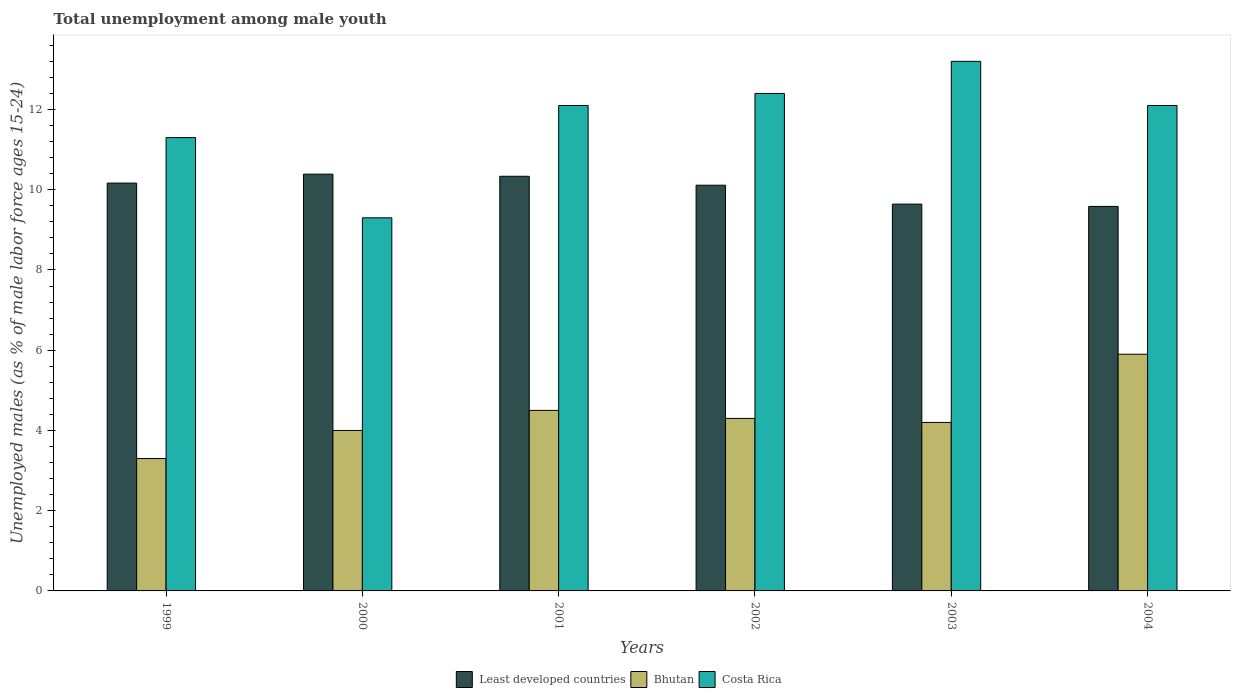How many groups of bars are there?
Your answer should be very brief. 6. Are the number of bars per tick equal to the number of legend labels?
Your answer should be very brief. Yes. How many bars are there on the 2nd tick from the left?
Ensure brevity in your answer.  3. In how many cases, is the number of bars for a given year not equal to the number of legend labels?
Make the answer very short. 0. What is the percentage of unemployed males in in Least developed countries in 2003?
Ensure brevity in your answer.  9.64. Across all years, what is the maximum percentage of unemployed males in in Least developed countries?
Make the answer very short. 10.39. Across all years, what is the minimum percentage of unemployed males in in Costa Rica?
Provide a succinct answer. 9.3. What is the total percentage of unemployed males in in Bhutan in the graph?
Offer a terse response. 26.2. What is the difference between the percentage of unemployed males in in Least developed countries in 2003 and that in 2004?
Offer a very short reply. 0.06. What is the difference between the percentage of unemployed males in in Bhutan in 2000 and the percentage of unemployed males in in Costa Rica in 2004?
Your answer should be very brief. -8.1. What is the average percentage of unemployed males in in Least developed countries per year?
Make the answer very short. 10.04. In the year 1999, what is the difference between the percentage of unemployed males in in Costa Rica and percentage of unemployed males in in Least developed countries?
Your response must be concise. 1.13. In how many years, is the percentage of unemployed males in in Bhutan greater than 11.2 %?
Give a very brief answer. 0. What is the ratio of the percentage of unemployed males in in Bhutan in 2001 to that in 2003?
Give a very brief answer. 1.07. What is the difference between the highest and the second highest percentage of unemployed males in in Costa Rica?
Give a very brief answer. 0.8. What is the difference between the highest and the lowest percentage of unemployed males in in Costa Rica?
Make the answer very short. 3.9. What does the 1st bar from the left in 2003 represents?
Your answer should be very brief. Least developed countries. What does the 2nd bar from the right in 2003 represents?
Keep it short and to the point. Bhutan. How many bars are there?
Your answer should be very brief. 18. Are all the bars in the graph horizontal?
Your response must be concise. No. How many years are there in the graph?
Offer a very short reply. 6. Does the graph contain grids?
Your answer should be compact. No. How many legend labels are there?
Offer a terse response. 3. How are the legend labels stacked?
Make the answer very short. Horizontal. What is the title of the graph?
Offer a terse response. Total unemployment among male youth. What is the label or title of the Y-axis?
Your response must be concise. Unemployed males (as % of male labor force ages 15-24). What is the Unemployed males (as % of male labor force ages 15-24) of Least developed countries in 1999?
Offer a very short reply. 10.17. What is the Unemployed males (as % of male labor force ages 15-24) of Bhutan in 1999?
Your answer should be very brief. 3.3. What is the Unemployed males (as % of male labor force ages 15-24) of Costa Rica in 1999?
Your response must be concise. 11.3. What is the Unemployed males (as % of male labor force ages 15-24) in Least developed countries in 2000?
Ensure brevity in your answer.  10.39. What is the Unemployed males (as % of male labor force ages 15-24) in Costa Rica in 2000?
Give a very brief answer. 9.3. What is the Unemployed males (as % of male labor force ages 15-24) in Least developed countries in 2001?
Offer a terse response. 10.34. What is the Unemployed males (as % of male labor force ages 15-24) in Bhutan in 2001?
Provide a succinct answer. 4.5. What is the Unemployed males (as % of male labor force ages 15-24) in Costa Rica in 2001?
Your answer should be very brief. 12.1. What is the Unemployed males (as % of male labor force ages 15-24) in Least developed countries in 2002?
Keep it short and to the point. 10.11. What is the Unemployed males (as % of male labor force ages 15-24) in Bhutan in 2002?
Make the answer very short. 4.3. What is the Unemployed males (as % of male labor force ages 15-24) in Costa Rica in 2002?
Your answer should be compact. 12.4. What is the Unemployed males (as % of male labor force ages 15-24) in Least developed countries in 2003?
Offer a terse response. 9.64. What is the Unemployed males (as % of male labor force ages 15-24) of Bhutan in 2003?
Offer a terse response. 4.2. What is the Unemployed males (as % of male labor force ages 15-24) of Costa Rica in 2003?
Offer a terse response. 13.2. What is the Unemployed males (as % of male labor force ages 15-24) in Least developed countries in 2004?
Your response must be concise. 9.58. What is the Unemployed males (as % of male labor force ages 15-24) in Bhutan in 2004?
Make the answer very short. 5.9. What is the Unemployed males (as % of male labor force ages 15-24) in Costa Rica in 2004?
Make the answer very short. 12.1. Across all years, what is the maximum Unemployed males (as % of male labor force ages 15-24) in Least developed countries?
Keep it short and to the point. 10.39. Across all years, what is the maximum Unemployed males (as % of male labor force ages 15-24) in Bhutan?
Ensure brevity in your answer.  5.9. Across all years, what is the maximum Unemployed males (as % of male labor force ages 15-24) of Costa Rica?
Your answer should be compact. 13.2. Across all years, what is the minimum Unemployed males (as % of male labor force ages 15-24) in Least developed countries?
Your answer should be very brief. 9.58. Across all years, what is the minimum Unemployed males (as % of male labor force ages 15-24) in Bhutan?
Offer a very short reply. 3.3. Across all years, what is the minimum Unemployed males (as % of male labor force ages 15-24) in Costa Rica?
Offer a very short reply. 9.3. What is the total Unemployed males (as % of male labor force ages 15-24) in Least developed countries in the graph?
Offer a very short reply. 60.23. What is the total Unemployed males (as % of male labor force ages 15-24) in Bhutan in the graph?
Keep it short and to the point. 26.2. What is the total Unemployed males (as % of male labor force ages 15-24) of Costa Rica in the graph?
Offer a very short reply. 70.4. What is the difference between the Unemployed males (as % of male labor force ages 15-24) of Least developed countries in 1999 and that in 2000?
Provide a succinct answer. -0.22. What is the difference between the Unemployed males (as % of male labor force ages 15-24) in Costa Rica in 1999 and that in 2000?
Keep it short and to the point. 2. What is the difference between the Unemployed males (as % of male labor force ages 15-24) in Least developed countries in 1999 and that in 2001?
Your response must be concise. -0.17. What is the difference between the Unemployed males (as % of male labor force ages 15-24) in Costa Rica in 1999 and that in 2001?
Your answer should be very brief. -0.8. What is the difference between the Unemployed males (as % of male labor force ages 15-24) of Least developed countries in 1999 and that in 2002?
Keep it short and to the point. 0.05. What is the difference between the Unemployed males (as % of male labor force ages 15-24) of Bhutan in 1999 and that in 2002?
Provide a succinct answer. -1. What is the difference between the Unemployed males (as % of male labor force ages 15-24) of Costa Rica in 1999 and that in 2002?
Your answer should be very brief. -1.1. What is the difference between the Unemployed males (as % of male labor force ages 15-24) in Least developed countries in 1999 and that in 2003?
Make the answer very short. 0.52. What is the difference between the Unemployed males (as % of male labor force ages 15-24) in Bhutan in 1999 and that in 2003?
Offer a very short reply. -0.9. What is the difference between the Unemployed males (as % of male labor force ages 15-24) in Costa Rica in 1999 and that in 2003?
Ensure brevity in your answer.  -1.9. What is the difference between the Unemployed males (as % of male labor force ages 15-24) of Least developed countries in 1999 and that in 2004?
Offer a terse response. 0.58. What is the difference between the Unemployed males (as % of male labor force ages 15-24) of Costa Rica in 1999 and that in 2004?
Make the answer very short. -0.8. What is the difference between the Unemployed males (as % of male labor force ages 15-24) in Least developed countries in 2000 and that in 2001?
Ensure brevity in your answer.  0.05. What is the difference between the Unemployed males (as % of male labor force ages 15-24) in Least developed countries in 2000 and that in 2002?
Give a very brief answer. 0.28. What is the difference between the Unemployed males (as % of male labor force ages 15-24) of Bhutan in 2000 and that in 2002?
Your response must be concise. -0.3. What is the difference between the Unemployed males (as % of male labor force ages 15-24) of Costa Rica in 2000 and that in 2002?
Provide a succinct answer. -3.1. What is the difference between the Unemployed males (as % of male labor force ages 15-24) of Least developed countries in 2000 and that in 2003?
Give a very brief answer. 0.75. What is the difference between the Unemployed males (as % of male labor force ages 15-24) in Costa Rica in 2000 and that in 2003?
Offer a very short reply. -3.9. What is the difference between the Unemployed males (as % of male labor force ages 15-24) in Least developed countries in 2000 and that in 2004?
Give a very brief answer. 0.8. What is the difference between the Unemployed males (as % of male labor force ages 15-24) in Costa Rica in 2000 and that in 2004?
Provide a succinct answer. -2.8. What is the difference between the Unemployed males (as % of male labor force ages 15-24) of Least developed countries in 2001 and that in 2002?
Offer a terse response. 0.22. What is the difference between the Unemployed males (as % of male labor force ages 15-24) in Bhutan in 2001 and that in 2002?
Give a very brief answer. 0.2. What is the difference between the Unemployed males (as % of male labor force ages 15-24) of Costa Rica in 2001 and that in 2002?
Give a very brief answer. -0.3. What is the difference between the Unemployed males (as % of male labor force ages 15-24) of Least developed countries in 2001 and that in 2003?
Offer a terse response. 0.69. What is the difference between the Unemployed males (as % of male labor force ages 15-24) in Bhutan in 2001 and that in 2003?
Ensure brevity in your answer.  0.3. What is the difference between the Unemployed males (as % of male labor force ages 15-24) in Least developed countries in 2001 and that in 2004?
Offer a very short reply. 0.75. What is the difference between the Unemployed males (as % of male labor force ages 15-24) in Bhutan in 2001 and that in 2004?
Make the answer very short. -1.4. What is the difference between the Unemployed males (as % of male labor force ages 15-24) in Least developed countries in 2002 and that in 2003?
Your response must be concise. 0.47. What is the difference between the Unemployed males (as % of male labor force ages 15-24) of Bhutan in 2002 and that in 2003?
Provide a succinct answer. 0.1. What is the difference between the Unemployed males (as % of male labor force ages 15-24) in Least developed countries in 2002 and that in 2004?
Offer a terse response. 0.53. What is the difference between the Unemployed males (as % of male labor force ages 15-24) of Bhutan in 2002 and that in 2004?
Your answer should be compact. -1.6. What is the difference between the Unemployed males (as % of male labor force ages 15-24) in Least developed countries in 2003 and that in 2004?
Ensure brevity in your answer.  0.06. What is the difference between the Unemployed males (as % of male labor force ages 15-24) of Costa Rica in 2003 and that in 2004?
Ensure brevity in your answer.  1.1. What is the difference between the Unemployed males (as % of male labor force ages 15-24) in Least developed countries in 1999 and the Unemployed males (as % of male labor force ages 15-24) in Bhutan in 2000?
Keep it short and to the point. 6.17. What is the difference between the Unemployed males (as % of male labor force ages 15-24) of Least developed countries in 1999 and the Unemployed males (as % of male labor force ages 15-24) of Costa Rica in 2000?
Ensure brevity in your answer.  0.87. What is the difference between the Unemployed males (as % of male labor force ages 15-24) of Least developed countries in 1999 and the Unemployed males (as % of male labor force ages 15-24) of Bhutan in 2001?
Give a very brief answer. 5.67. What is the difference between the Unemployed males (as % of male labor force ages 15-24) of Least developed countries in 1999 and the Unemployed males (as % of male labor force ages 15-24) of Costa Rica in 2001?
Your response must be concise. -1.93. What is the difference between the Unemployed males (as % of male labor force ages 15-24) of Bhutan in 1999 and the Unemployed males (as % of male labor force ages 15-24) of Costa Rica in 2001?
Provide a succinct answer. -8.8. What is the difference between the Unemployed males (as % of male labor force ages 15-24) in Least developed countries in 1999 and the Unemployed males (as % of male labor force ages 15-24) in Bhutan in 2002?
Your answer should be compact. 5.87. What is the difference between the Unemployed males (as % of male labor force ages 15-24) of Least developed countries in 1999 and the Unemployed males (as % of male labor force ages 15-24) of Costa Rica in 2002?
Give a very brief answer. -2.23. What is the difference between the Unemployed males (as % of male labor force ages 15-24) of Least developed countries in 1999 and the Unemployed males (as % of male labor force ages 15-24) of Bhutan in 2003?
Provide a succinct answer. 5.97. What is the difference between the Unemployed males (as % of male labor force ages 15-24) in Least developed countries in 1999 and the Unemployed males (as % of male labor force ages 15-24) in Costa Rica in 2003?
Provide a succinct answer. -3.03. What is the difference between the Unemployed males (as % of male labor force ages 15-24) of Bhutan in 1999 and the Unemployed males (as % of male labor force ages 15-24) of Costa Rica in 2003?
Make the answer very short. -9.9. What is the difference between the Unemployed males (as % of male labor force ages 15-24) in Least developed countries in 1999 and the Unemployed males (as % of male labor force ages 15-24) in Bhutan in 2004?
Ensure brevity in your answer.  4.27. What is the difference between the Unemployed males (as % of male labor force ages 15-24) of Least developed countries in 1999 and the Unemployed males (as % of male labor force ages 15-24) of Costa Rica in 2004?
Offer a terse response. -1.93. What is the difference between the Unemployed males (as % of male labor force ages 15-24) of Least developed countries in 2000 and the Unemployed males (as % of male labor force ages 15-24) of Bhutan in 2001?
Give a very brief answer. 5.89. What is the difference between the Unemployed males (as % of male labor force ages 15-24) in Least developed countries in 2000 and the Unemployed males (as % of male labor force ages 15-24) in Costa Rica in 2001?
Offer a terse response. -1.71. What is the difference between the Unemployed males (as % of male labor force ages 15-24) of Least developed countries in 2000 and the Unemployed males (as % of male labor force ages 15-24) of Bhutan in 2002?
Your answer should be compact. 6.09. What is the difference between the Unemployed males (as % of male labor force ages 15-24) in Least developed countries in 2000 and the Unemployed males (as % of male labor force ages 15-24) in Costa Rica in 2002?
Provide a succinct answer. -2.01. What is the difference between the Unemployed males (as % of male labor force ages 15-24) of Bhutan in 2000 and the Unemployed males (as % of male labor force ages 15-24) of Costa Rica in 2002?
Ensure brevity in your answer.  -8.4. What is the difference between the Unemployed males (as % of male labor force ages 15-24) in Least developed countries in 2000 and the Unemployed males (as % of male labor force ages 15-24) in Bhutan in 2003?
Make the answer very short. 6.19. What is the difference between the Unemployed males (as % of male labor force ages 15-24) of Least developed countries in 2000 and the Unemployed males (as % of male labor force ages 15-24) of Costa Rica in 2003?
Provide a short and direct response. -2.81. What is the difference between the Unemployed males (as % of male labor force ages 15-24) in Least developed countries in 2000 and the Unemployed males (as % of male labor force ages 15-24) in Bhutan in 2004?
Your answer should be very brief. 4.49. What is the difference between the Unemployed males (as % of male labor force ages 15-24) in Least developed countries in 2000 and the Unemployed males (as % of male labor force ages 15-24) in Costa Rica in 2004?
Keep it short and to the point. -1.71. What is the difference between the Unemployed males (as % of male labor force ages 15-24) in Least developed countries in 2001 and the Unemployed males (as % of male labor force ages 15-24) in Bhutan in 2002?
Provide a short and direct response. 6.04. What is the difference between the Unemployed males (as % of male labor force ages 15-24) of Least developed countries in 2001 and the Unemployed males (as % of male labor force ages 15-24) of Costa Rica in 2002?
Make the answer very short. -2.06. What is the difference between the Unemployed males (as % of male labor force ages 15-24) of Least developed countries in 2001 and the Unemployed males (as % of male labor force ages 15-24) of Bhutan in 2003?
Provide a succinct answer. 6.14. What is the difference between the Unemployed males (as % of male labor force ages 15-24) of Least developed countries in 2001 and the Unemployed males (as % of male labor force ages 15-24) of Costa Rica in 2003?
Provide a short and direct response. -2.86. What is the difference between the Unemployed males (as % of male labor force ages 15-24) in Bhutan in 2001 and the Unemployed males (as % of male labor force ages 15-24) in Costa Rica in 2003?
Provide a succinct answer. -8.7. What is the difference between the Unemployed males (as % of male labor force ages 15-24) of Least developed countries in 2001 and the Unemployed males (as % of male labor force ages 15-24) of Bhutan in 2004?
Your answer should be compact. 4.44. What is the difference between the Unemployed males (as % of male labor force ages 15-24) of Least developed countries in 2001 and the Unemployed males (as % of male labor force ages 15-24) of Costa Rica in 2004?
Your answer should be compact. -1.76. What is the difference between the Unemployed males (as % of male labor force ages 15-24) in Least developed countries in 2002 and the Unemployed males (as % of male labor force ages 15-24) in Bhutan in 2003?
Make the answer very short. 5.91. What is the difference between the Unemployed males (as % of male labor force ages 15-24) of Least developed countries in 2002 and the Unemployed males (as % of male labor force ages 15-24) of Costa Rica in 2003?
Give a very brief answer. -3.09. What is the difference between the Unemployed males (as % of male labor force ages 15-24) in Bhutan in 2002 and the Unemployed males (as % of male labor force ages 15-24) in Costa Rica in 2003?
Make the answer very short. -8.9. What is the difference between the Unemployed males (as % of male labor force ages 15-24) of Least developed countries in 2002 and the Unemployed males (as % of male labor force ages 15-24) of Bhutan in 2004?
Provide a succinct answer. 4.21. What is the difference between the Unemployed males (as % of male labor force ages 15-24) of Least developed countries in 2002 and the Unemployed males (as % of male labor force ages 15-24) of Costa Rica in 2004?
Offer a terse response. -1.99. What is the difference between the Unemployed males (as % of male labor force ages 15-24) in Bhutan in 2002 and the Unemployed males (as % of male labor force ages 15-24) in Costa Rica in 2004?
Offer a very short reply. -7.8. What is the difference between the Unemployed males (as % of male labor force ages 15-24) in Least developed countries in 2003 and the Unemployed males (as % of male labor force ages 15-24) in Bhutan in 2004?
Ensure brevity in your answer.  3.74. What is the difference between the Unemployed males (as % of male labor force ages 15-24) of Least developed countries in 2003 and the Unemployed males (as % of male labor force ages 15-24) of Costa Rica in 2004?
Ensure brevity in your answer.  -2.46. What is the difference between the Unemployed males (as % of male labor force ages 15-24) in Bhutan in 2003 and the Unemployed males (as % of male labor force ages 15-24) in Costa Rica in 2004?
Offer a terse response. -7.9. What is the average Unemployed males (as % of male labor force ages 15-24) in Least developed countries per year?
Provide a short and direct response. 10.04. What is the average Unemployed males (as % of male labor force ages 15-24) of Bhutan per year?
Provide a short and direct response. 4.37. What is the average Unemployed males (as % of male labor force ages 15-24) in Costa Rica per year?
Ensure brevity in your answer.  11.73. In the year 1999, what is the difference between the Unemployed males (as % of male labor force ages 15-24) in Least developed countries and Unemployed males (as % of male labor force ages 15-24) in Bhutan?
Give a very brief answer. 6.87. In the year 1999, what is the difference between the Unemployed males (as % of male labor force ages 15-24) in Least developed countries and Unemployed males (as % of male labor force ages 15-24) in Costa Rica?
Your answer should be very brief. -1.13. In the year 1999, what is the difference between the Unemployed males (as % of male labor force ages 15-24) in Bhutan and Unemployed males (as % of male labor force ages 15-24) in Costa Rica?
Offer a terse response. -8. In the year 2000, what is the difference between the Unemployed males (as % of male labor force ages 15-24) of Least developed countries and Unemployed males (as % of male labor force ages 15-24) of Bhutan?
Your answer should be very brief. 6.39. In the year 2000, what is the difference between the Unemployed males (as % of male labor force ages 15-24) in Least developed countries and Unemployed males (as % of male labor force ages 15-24) in Costa Rica?
Give a very brief answer. 1.09. In the year 2001, what is the difference between the Unemployed males (as % of male labor force ages 15-24) of Least developed countries and Unemployed males (as % of male labor force ages 15-24) of Bhutan?
Your answer should be compact. 5.84. In the year 2001, what is the difference between the Unemployed males (as % of male labor force ages 15-24) of Least developed countries and Unemployed males (as % of male labor force ages 15-24) of Costa Rica?
Offer a very short reply. -1.76. In the year 2001, what is the difference between the Unemployed males (as % of male labor force ages 15-24) of Bhutan and Unemployed males (as % of male labor force ages 15-24) of Costa Rica?
Your response must be concise. -7.6. In the year 2002, what is the difference between the Unemployed males (as % of male labor force ages 15-24) of Least developed countries and Unemployed males (as % of male labor force ages 15-24) of Bhutan?
Your response must be concise. 5.81. In the year 2002, what is the difference between the Unemployed males (as % of male labor force ages 15-24) of Least developed countries and Unemployed males (as % of male labor force ages 15-24) of Costa Rica?
Your answer should be very brief. -2.29. In the year 2002, what is the difference between the Unemployed males (as % of male labor force ages 15-24) in Bhutan and Unemployed males (as % of male labor force ages 15-24) in Costa Rica?
Keep it short and to the point. -8.1. In the year 2003, what is the difference between the Unemployed males (as % of male labor force ages 15-24) in Least developed countries and Unemployed males (as % of male labor force ages 15-24) in Bhutan?
Keep it short and to the point. 5.44. In the year 2003, what is the difference between the Unemployed males (as % of male labor force ages 15-24) in Least developed countries and Unemployed males (as % of male labor force ages 15-24) in Costa Rica?
Ensure brevity in your answer.  -3.56. In the year 2004, what is the difference between the Unemployed males (as % of male labor force ages 15-24) of Least developed countries and Unemployed males (as % of male labor force ages 15-24) of Bhutan?
Keep it short and to the point. 3.68. In the year 2004, what is the difference between the Unemployed males (as % of male labor force ages 15-24) in Least developed countries and Unemployed males (as % of male labor force ages 15-24) in Costa Rica?
Provide a short and direct response. -2.52. In the year 2004, what is the difference between the Unemployed males (as % of male labor force ages 15-24) in Bhutan and Unemployed males (as % of male labor force ages 15-24) in Costa Rica?
Keep it short and to the point. -6.2. What is the ratio of the Unemployed males (as % of male labor force ages 15-24) in Least developed countries in 1999 to that in 2000?
Your answer should be very brief. 0.98. What is the ratio of the Unemployed males (as % of male labor force ages 15-24) in Bhutan in 1999 to that in 2000?
Give a very brief answer. 0.82. What is the ratio of the Unemployed males (as % of male labor force ages 15-24) of Costa Rica in 1999 to that in 2000?
Make the answer very short. 1.22. What is the ratio of the Unemployed males (as % of male labor force ages 15-24) of Least developed countries in 1999 to that in 2001?
Ensure brevity in your answer.  0.98. What is the ratio of the Unemployed males (as % of male labor force ages 15-24) in Bhutan in 1999 to that in 2001?
Ensure brevity in your answer.  0.73. What is the ratio of the Unemployed males (as % of male labor force ages 15-24) in Costa Rica in 1999 to that in 2001?
Give a very brief answer. 0.93. What is the ratio of the Unemployed males (as % of male labor force ages 15-24) of Bhutan in 1999 to that in 2002?
Provide a short and direct response. 0.77. What is the ratio of the Unemployed males (as % of male labor force ages 15-24) of Costa Rica in 1999 to that in 2002?
Make the answer very short. 0.91. What is the ratio of the Unemployed males (as % of male labor force ages 15-24) of Least developed countries in 1999 to that in 2003?
Your answer should be compact. 1.05. What is the ratio of the Unemployed males (as % of male labor force ages 15-24) of Bhutan in 1999 to that in 2003?
Your answer should be very brief. 0.79. What is the ratio of the Unemployed males (as % of male labor force ages 15-24) in Costa Rica in 1999 to that in 2003?
Your response must be concise. 0.86. What is the ratio of the Unemployed males (as % of male labor force ages 15-24) in Least developed countries in 1999 to that in 2004?
Provide a succinct answer. 1.06. What is the ratio of the Unemployed males (as % of male labor force ages 15-24) of Bhutan in 1999 to that in 2004?
Make the answer very short. 0.56. What is the ratio of the Unemployed males (as % of male labor force ages 15-24) in Costa Rica in 1999 to that in 2004?
Provide a succinct answer. 0.93. What is the ratio of the Unemployed males (as % of male labor force ages 15-24) of Least developed countries in 2000 to that in 2001?
Give a very brief answer. 1.01. What is the ratio of the Unemployed males (as % of male labor force ages 15-24) of Costa Rica in 2000 to that in 2001?
Your answer should be compact. 0.77. What is the ratio of the Unemployed males (as % of male labor force ages 15-24) of Least developed countries in 2000 to that in 2002?
Your response must be concise. 1.03. What is the ratio of the Unemployed males (as % of male labor force ages 15-24) of Bhutan in 2000 to that in 2002?
Your response must be concise. 0.93. What is the ratio of the Unemployed males (as % of male labor force ages 15-24) of Least developed countries in 2000 to that in 2003?
Your answer should be compact. 1.08. What is the ratio of the Unemployed males (as % of male labor force ages 15-24) in Bhutan in 2000 to that in 2003?
Offer a very short reply. 0.95. What is the ratio of the Unemployed males (as % of male labor force ages 15-24) of Costa Rica in 2000 to that in 2003?
Offer a very short reply. 0.7. What is the ratio of the Unemployed males (as % of male labor force ages 15-24) in Least developed countries in 2000 to that in 2004?
Offer a terse response. 1.08. What is the ratio of the Unemployed males (as % of male labor force ages 15-24) of Bhutan in 2000 to that in 2004?
Provide a succinct answer. 0.68. What is the ratio of the Unemployed males (as % of male labor force ages 15-24) in Costa Rica in 2000 to that in 2004?
Keep it short and to the point. 0.77. What is the ratio of the Unemployed males (as % of male labor force ages 15-24) of Bhutan in 2001 to that in 2002?
Offer a very short reply. 1.05. What is the ratio of the Unemployed males (as % of male labor force ages 15-24) of Costa Rica in 2001 to that in 2002?
Offer a very short reply. 0.98. What is the ratio of the Unemployed males (as % of male labor force ages 15-24) in Least developed countries in 2001 to that in 2003?
Ensure brevity in your answer.  1.07. What is the ratio of the Unemployed males (as % of male labor force ages 15-24) of Bhutan in 2001 to that in 2003?
Keep it short and to the point. 1.07. What is the ratio of the Unemployed males (as % of male labor force ages 15-24) in Least developed countries in 2001 to that in 2004?
Offer a terse response. 1.08. What is the ratio of the Unemployed males (as % of male labor force ages 15-24) in Bhutan in 2001 to that in 2004?
Make the answer very short. 0.76. What is the ratio of the Unemployed males (as % of male labor force ages 15-24) in Costa Rica in 2001 to that in 2004?
Provide a succinct answer. 1. What is the ratio of the Unemployed males (as % of male labor force ages 15-24) in Least developed countries in 2002 to that in 2003?
Give a very brief answer. 1.05. What is the ratio of the Unemployed males (as % of male labor force ages 15-24) in Bhutan in 2002 to that in 2003?
Keep it short and to the point. 1.02. What is the ratio of the Unemployed males (as % of male labor force ages 15-24) in Costa Rica in 2002 to that in 2003?
Your response must be concise. 0.94. What is the ratio of the Unemployed males (as % of male labor force ages 15-24) in Least developed countries in 2002 to that in 2004?
Your answer should be very brief. 1.06. What is the ratio of the Unemployed males (as % of male labor force ages 15-24) in Bhutan in 2002 to that in 2004?
Your answer should be compact. 0.73. What is the ratio of the Unemployed males (as % of male labor force ages 15-24) of Costa Rica in 2002 to that in 2004?
Your response must be concise. 1.02. What is the ratio of the Unemployed males (as % of male labor force ages 15-24) in Least developed countries in 2003 to that in 2004?
Your answer should be very brief. 1.01. What is the ratio of the Unemployed males (as % of male labor force ages 15-24) in Bhutan in 2003 to that in 2004?
Ensure brevity in your answer.  0.71. What is the ratio of the Unemployed males (as % of male labor force ages 15-24) in Costa Rica in 2003 to that in 2004?
Your response must be concise. 1.09. What is the difference between the highest and the second highest Unemployed males (as % of male labor force ages 15-24) in Least developed countries?
Make the answer very short. 0.05. What is the difference between the highest and the lowest Unemployed males (as % of male labor force ages 15-24) of Least developed countries?
Make the answer very short. 0.8. What is the difference between the highest and the lowest Unemployed males (as % of male labor force ages 15-24) of Bhutan?
Your answer should be very brief. 2.6. 